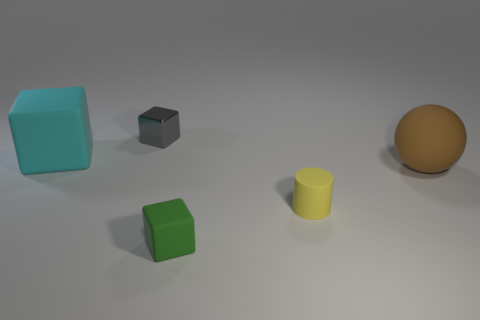Subtract all green cubes. How many cubes are left? 2 Add 1 large cyan blocks. How many objects exist? 6 Subtract all gray cubes. How many cubes are left? 2 Subtract all cubes. How many objects are left? 2 Subtract 0 blue balls. How many objects are left? 5 Subtract all yellow cubes. Subtract all green cylinders. How many cubes are left? 3 Subtract all purple blocks. How many blue cylinders are left? 0 Subtract all big green objects. Subtract all cyan matte objects. How many objects are left? 4 Add 5 gray things. How many gray things are left? 6 Add 2 large brown metallic blocks. How many large brown metallic blocks exist? 2 